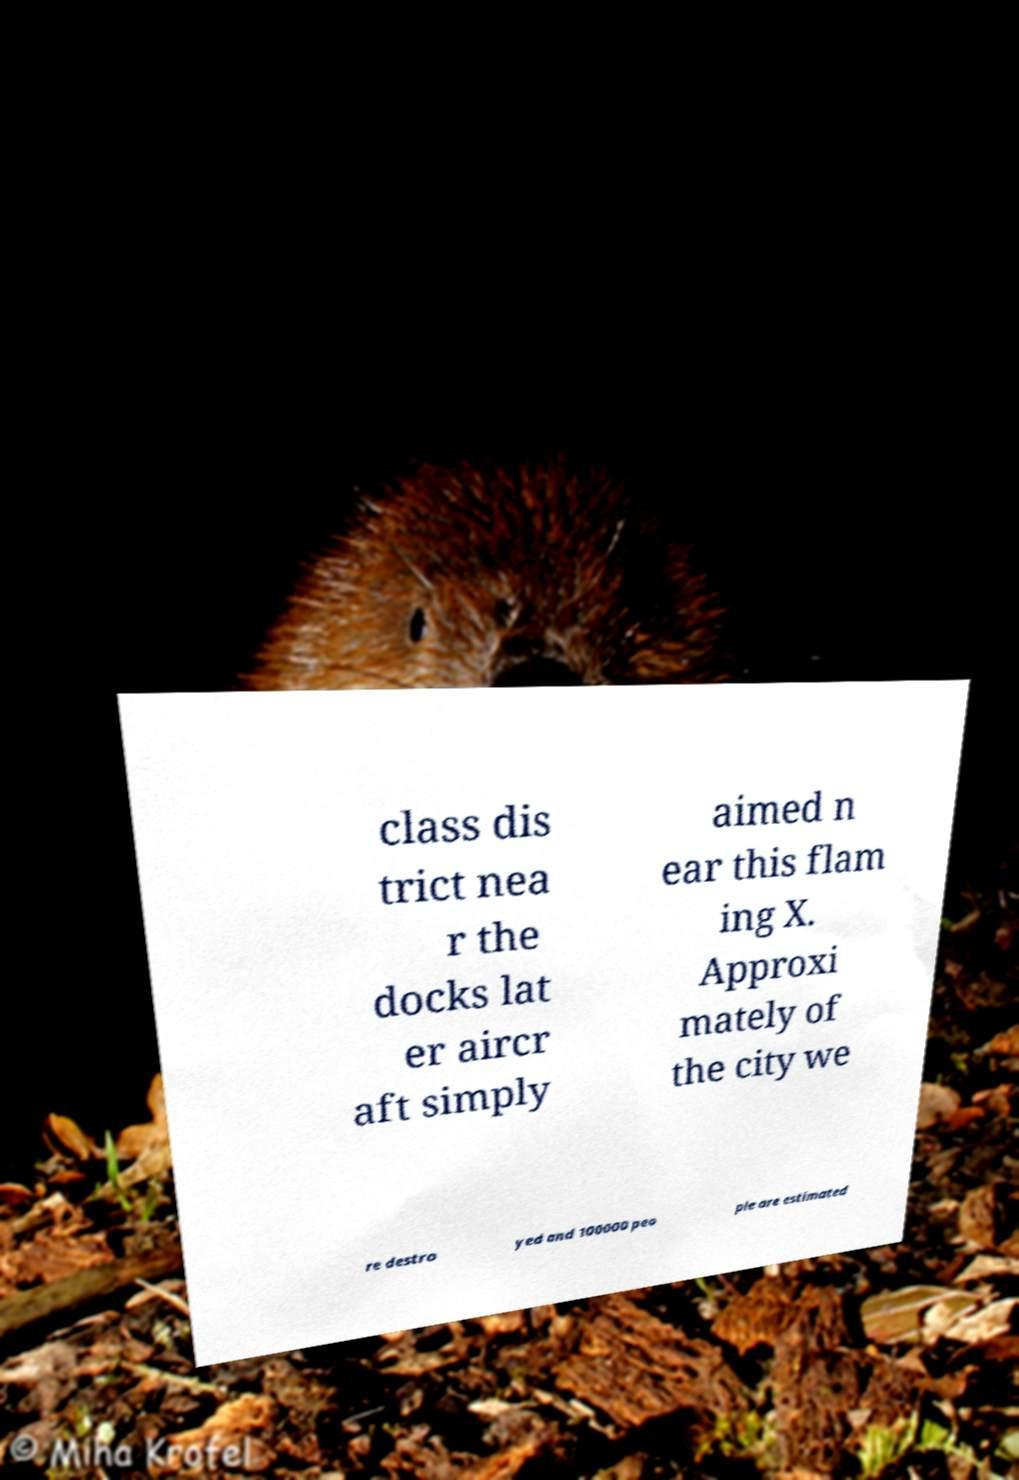Could you assist in decoding the text presented in this image and type it out clearly? class dis trict nea r the docks lat er aircr aft simply aimed n ear this flam ing X. Approxi mately of the city we re destro yed and 100000 peo ple are estimated 